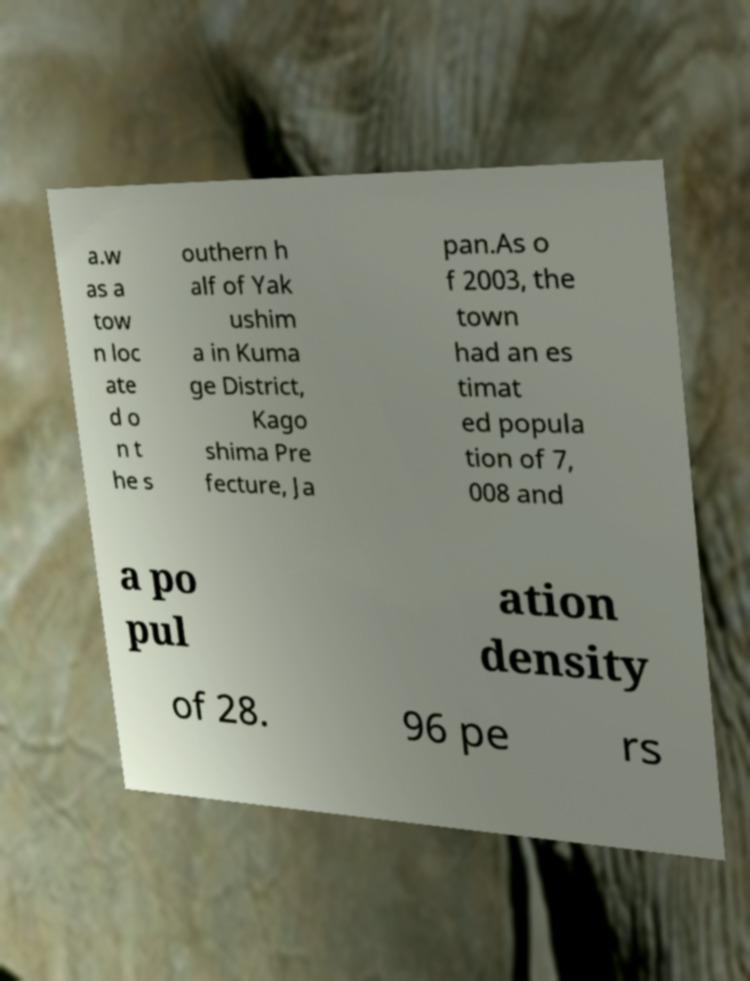Please read and relay the text visible in this image. What does it say? a.w as a tow n loc ate d o n t he s outhern h alf of Yak ushim a in Kuma ge District, Kago shima Pre fecture, Ja pan.As o f 2003, the town had an es timat ed popula tion of 7, 008 and a po pul ation density of 28. 96 pe rs 